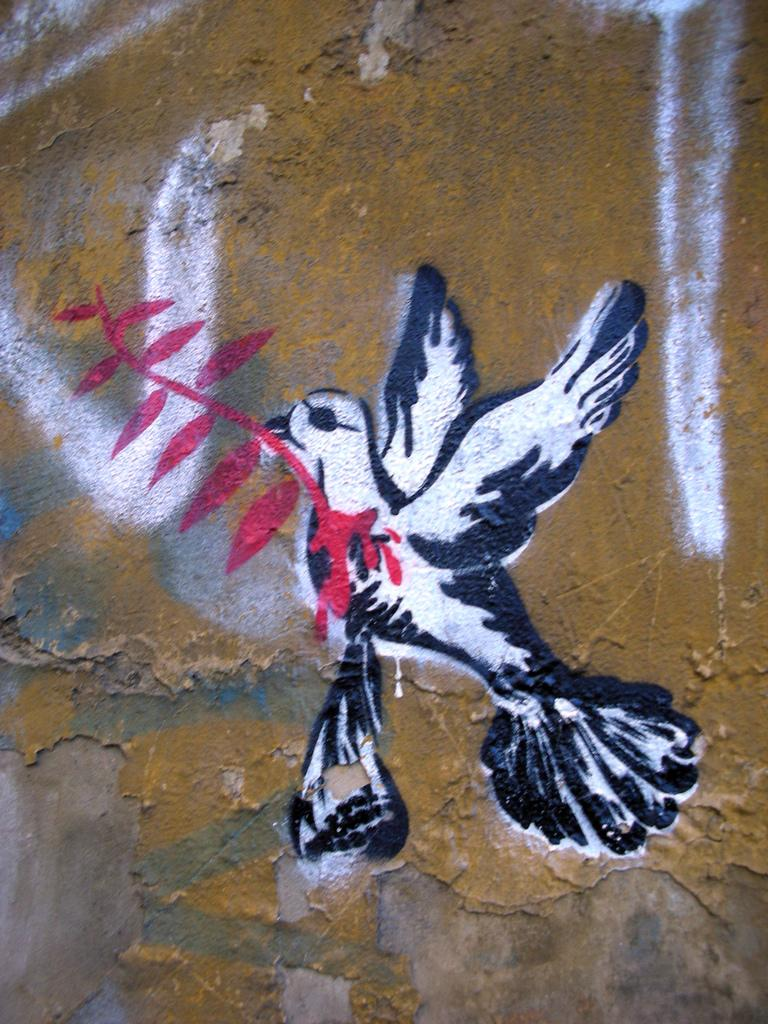What is the main subject of the art in the image? The main subject of the art in the image is a bird. Are there any other elements in the art besides the bird? Yes, there are other things depicted in the art. Where is the art located in the image? The art is on a surface that resembles a wall. Can you tell me which actor is performing in the image? There is no actor present in the image; it features an art piece with a bird as the main subject. What type of minister is depicted in the image? There is no minister depicted in the image; it features an art piece with a bird as the main subject. 